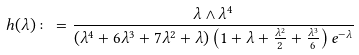Convert formula to latex. <formula><loc_0><loc_0><loc_500><loc_500>h ( \lambda ) \colon = \frac { \lambda \wedge \lambda ^ { 4 } } { ( \lambda ^ { 4 } + 6 \lambda ^ { 3 } + 7 \lambda ^ { 2 } + \lambda ) \left ( 1 + \lambda + \frac { \lambda ^ { 2 } } { 2 } + \frac { \lambda ^ { 3 } } { 6 } \right ) e ^ { - \lambda } }</formula> 